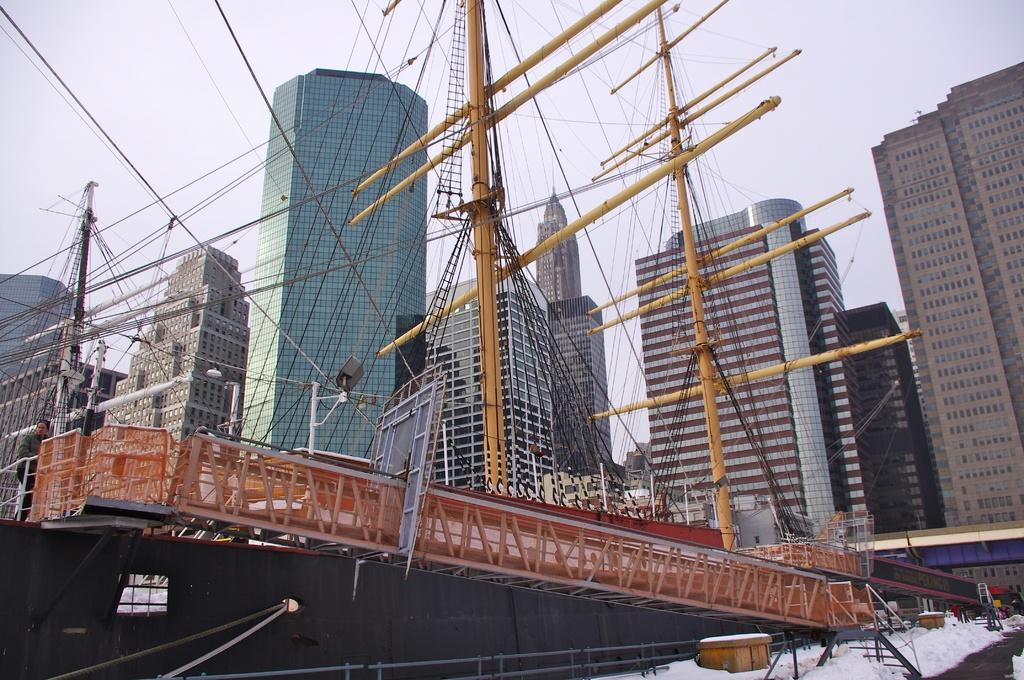Describe this image in one or two sentences. In this image we can see few buildings and poles, there are two wooden boxes on the snow, also we can see some people, wires, windows, fence and other objects, in the background we can see the sky. 